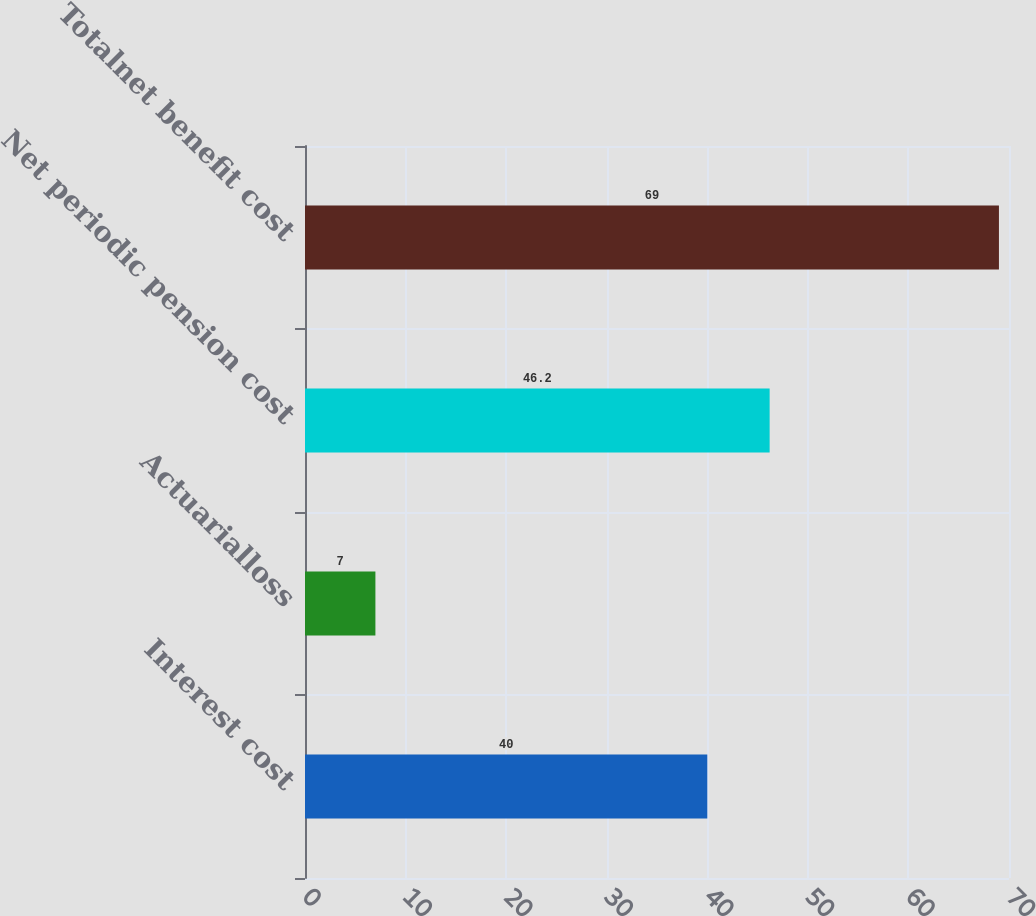<chart> <loc_0><loc_0><loc_500><loc_500><bar_chart><fcel>Interest cost<fcel>Actuarialloss<fcel>Net periodic pension cost<fcel>Totalnet benefit cost<nl><fcel>40<fcel>7<fcel>46.2<fcel>69<nl></chart> 